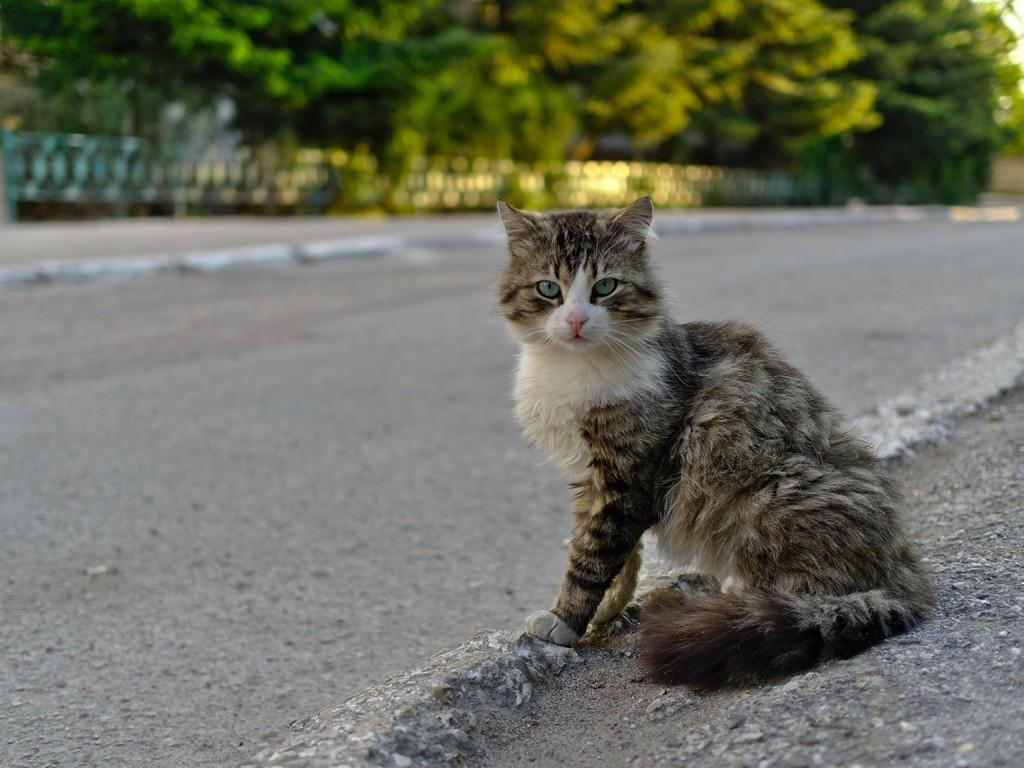What animal can be seen in the image? There is a cat in the image. Where is the cat located in the image? The cat is on the road. What can be seen in the background of the image? There are trees in the background of the image. What type of bean is being used as a prop in the image? There is no bean present in the image. How many houses can be seen in the image? There are no houses visible in the image; it features a cat on the road with trees in the background. 